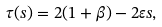Convert formula to latex. <formula><loc_0><loc_0><loc_500><loc_500>\tau ( s ) = 2 ( 1 + \beta ) - 2 \varepsilon s ,</formula> 